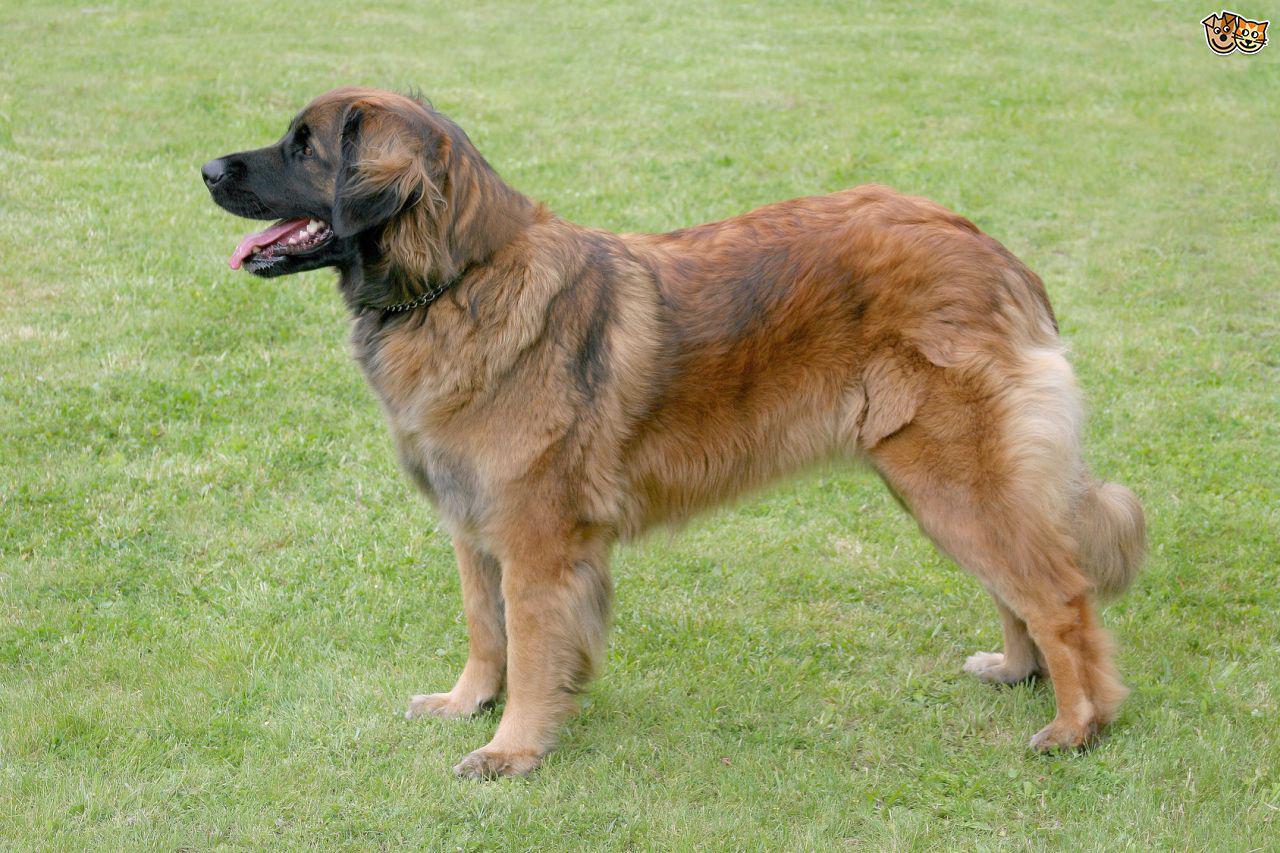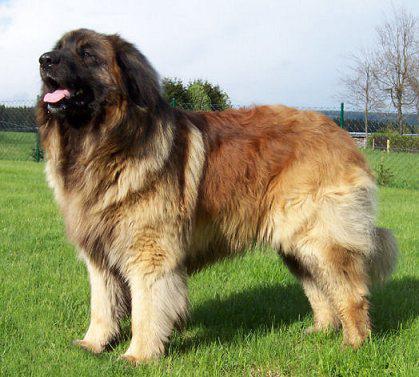The first image is the image on the left, the second image is the image on the right. Examine the images to the left and right. Is the description "Some dogs are sitting on the ground." accurate? Answer yes or no. No. The first image is the image on the left, the second image is the image on the right. Analyze the images presented: Is the assertion "Each dog's tongue is clearly visible." valid? Answer yes or no. Yes. 